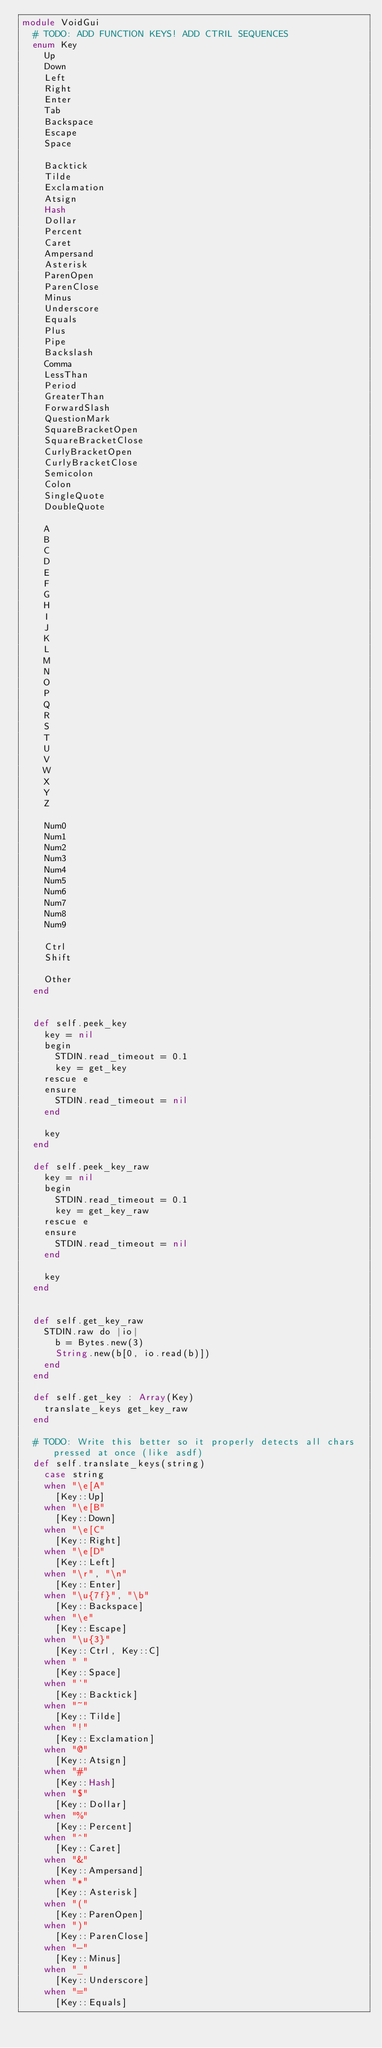<code> <loc_0><loc_0><loc_500><loc_500><_Crystal_>module VoidGui
  # TODO: ADD FUNCTION KEYS! ADD CTRIL SEQUENCES
  enum Key
    Up
    Down
    Left
    Right
    Enter
    Tab
    Backspace
    Escape
    Space

    Backtick
    Tilde
    Exclamation
    Atsign
    Hash
    Dollar
    Percent
    Caret
    Ampersand
    Asterisk
    ParenOpen
    ParenClose
    Minus
    Underscore
    Equals
    Plus
    Pipe
    Backslash
    Comma
    LessThan
    Period
    GreaterThan
    ForwardSlash
    QuestionMark
    SquareBracketOpen
    SquareBracketClose
    CurlyBracketOpen
    CurlyBracketClose
    Semicolon
    Colon
    SingleQuote
    DoubleQuote

    A
    B
    C
    D
    E
    F
    G
    H
    I
    J
    K
    L
    M
    N
    O
    P
    Q
    R
    S
    T
    U
    V
    W
    X
    Y
    Z

    Num0
    Num1
    Num2
    Num3
    Num4
    Num5
    Num6
    Num7
    Num8
    Num9

    Ctrl
    Shift

    Other
  end


  def self.peek_key
    key = nil
    begin
      STDIN.read_timeout = 0.1
      key = get_key
    rescue e
    ensure
      STDIN.read_timeout = nil
    end

    key
  end

  def self.peek_key_raw
    key = nil
    begin
      STDIN.read_timeout = 0.1
      key = get_key_raw
    rescue e
    ensure
      STDIN.read_timeout = nil
    end

    key
  end


  def self.get_key_raw
    STDIN.raw do |io|
      b = Bytes.new(3)
      String.new(b[0, io.read(b)])
    end
  end

  def self.get_key : Array(Key)
    translate_keys get_key_raw
  end

  # TODO: Write this better so it properly detects all chars pressed at once (like asdf)
  def self.translate_keys(string)
    case string
    when "\e[A"
      [Key::Up]
    when "\e[B"
      [Key::Down]
    when "\e[C"
      [Key::Right]
    when "\e[D"
      [Key::Left]
    when "\r", "\n"
      [Key::Enter]
    when "\u{7f}", "\b"
      [Key::Backspace]
    when "\e"
      [Key::Escape]
    when "\u{3}"
      [Key::Ctrl, Key::C]
    when " "
      [Key::Space]
    when "`"
      [Key::Backtick]
    when "~"
      [Key::Tilde]
    when "!"
      [Key::Exclamation]
    when "@"
      [Key::Atsign]
    when "#"
      [Key::Hash]
    when "$"
      [Key::Dollar]
    when "%"
      [Key::Percent]
    when "^"
      [Key::Caret]
    when "&"
      [Key::Ampersand]
    when "*"
      [Key::Asterisk]
    when "("
      [Key::ParenOpen]
    when ")"
      [Key::ParenClose]
    when "-"
      [Key::Minus]
    when "_"
      [Key::Underscore]
    when "="
      [Key::Equals]</code> 